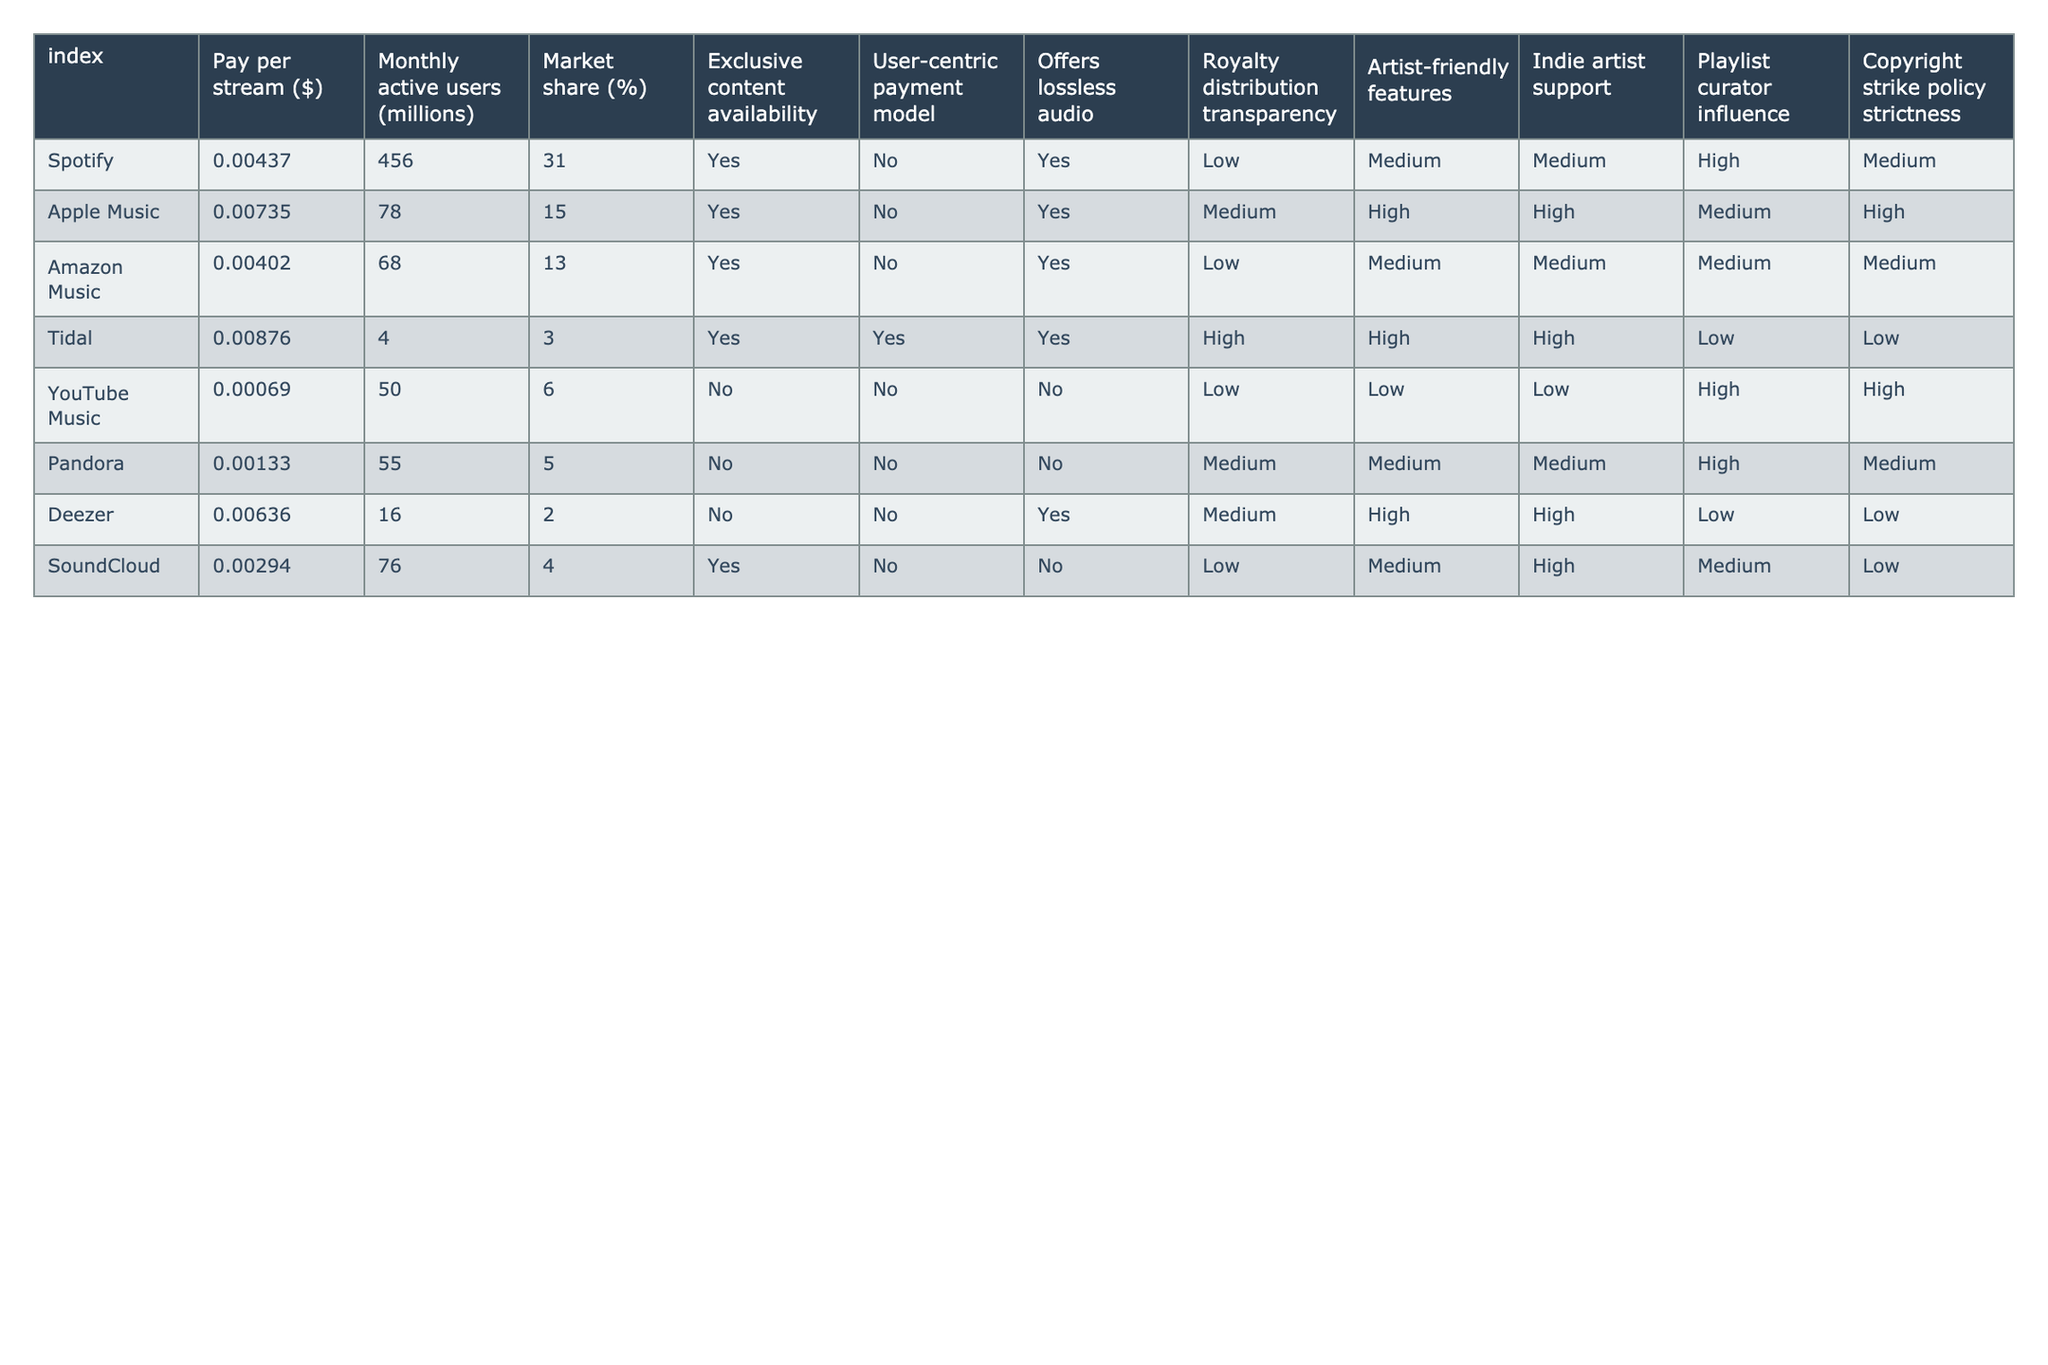What is the pay per stream for Spotify? The table shows that the pay per stream for Spotify is $0.00437.
Answer: $0.00437 Which platform has the highest pay per stream? According to the table, Tidal has the highest pay per stream at $0.00876.
Answer: Tidal Are all platforms offering exclusive content? The table indicates that not all platforms offer exclusive content; specifically, YouTube Music, Pandora, and Deezer do not.
Answer: No What is the market share percentage of Apple Music? The table lists Apple Music's market share as 15%.
Answer: 15% Which platform has the lowest royalty distribution transparency? The table shows that Spotify, Amazon Music, and YouTube Music have low transparency in royalty distribution.
Answer: Spotify, Amazon Music, YouTube Music How much is Amazon Music's pay per stream? The table indicates that Amazon Music's pay per stream is $0.00402.
Answer: $0.00402 Which platform is artist-friendly based on features? The table categorizes Tidal and Apple Music as having high artist-friendly features.
Answer: Tidal, Apple Music What is the average pay per stream across all platforms listed? To find the average pay per stream, sum all the pay per stream values (0.00437 + 0.00735 + 0.00402 + 0.00876 + 0.00069 + 0.00133 + 0.00636 + 0.00294) = 0.03582. Dividing by 8 gives an average of approximately $0.00448.
Answer: $0.00448 Which platforms support indie artists the most? According to the table, Apple Music and Tidal show the highest support for indie artists.
Answer: Apple Music, Tidal Is there any platform that offers lossless audio? Yes, the table indicates that Spotify, Apple Music, Amazon Music, and Tidal all offer lossless audio.
Answer: Yes Which platform has the fewest monthly active users? The table shows that Tidal has the fewest monthly active users, with only 4 million.
Answer: Tidal If we consider the platforms that have a medium artist-friendly feature rating, what are they? The table reveals that Spotify and Deezer have a medium rating for artist-friendly features.
Answer: Spotify, Deezer Which platform has the strictest copyright strike policy? The table indicates that Apple Music has the strictest copyright strike policy with a high rating.
Answer: Apple Music Which platform has the lowest number of monthly active users, and what is that number? Tidal has the lowest number of monthly active users at 4 million.
Answer: 4 million How do the exclusive content offerings relate to the user-centric payment model? The table shows that all platforms offering exclusive content also follow a non-user-centric payment model, except for Tidal, which uses a user-centric payment model. This indicates a potential link between exclusivity and payment styles.
Answer: Yes, generally linked 